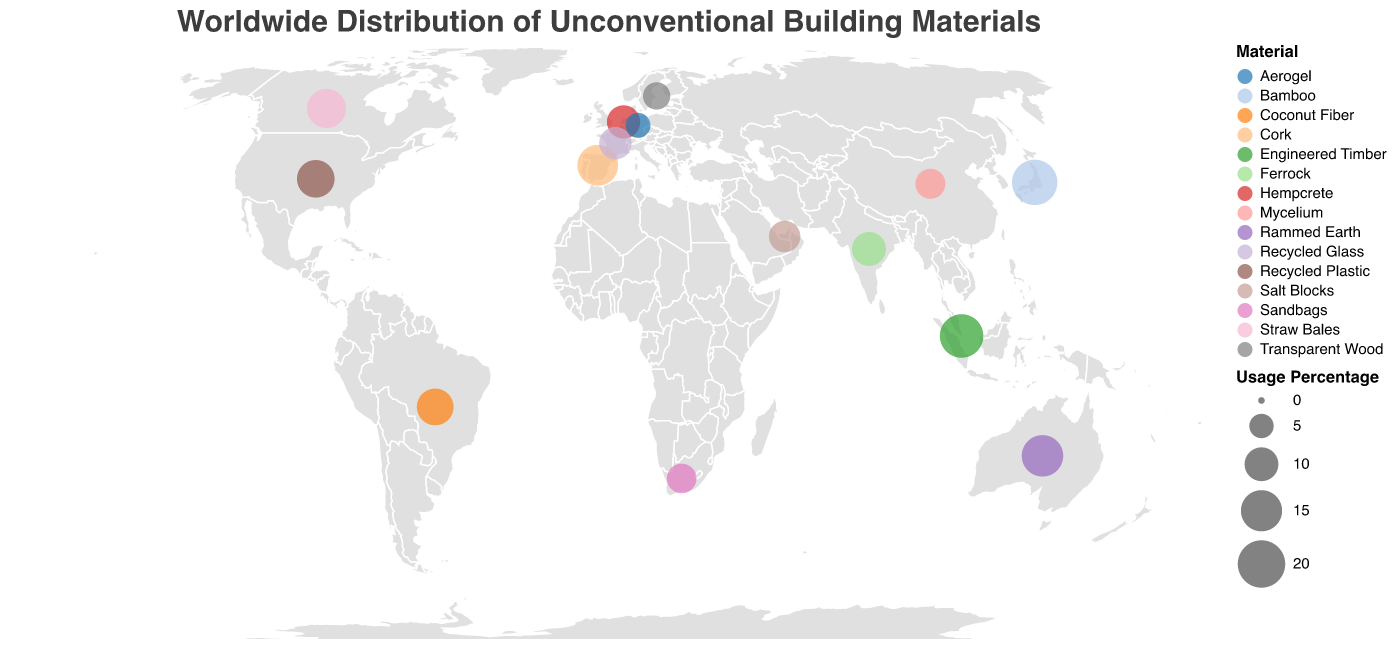What is the title of the figure? The title is usually at the top of the figure and describes its main topic. Here, it specifies the geographic distribution of unconventional building materials.
Answer: Worldwide Distribution of Unconventional Building Materials Which country has the highest usage percentage for their unconventional building material? By observing the size of the circles and the numerical values, the country with the highest percentage can be identified.
Answer: Japan What material is prominently used in Australia, and what is its usage percentage? Locate Australia on the map and look at the label and size of the circle corresponding to it.
Answer: Rammed Earth, 15.2% How does the usage percentage of Bamboo in Japan compare to Cork in Spain? Identify the usage percentages for both Bamboo in Japan and Cork in Spain, then compare these values.
Answer: Bamboo in Japan (18.3%) is higher than Cork in Spain (14.7%) Which materials are used in countries with a usage percentage greater than 15%? Identify all circles with sizes representing usage percentages greater than 15%, and then check the associated materials.
Answer: Bamboo in Japan, Rammed Earth in Australia, Engineered Timber in Singapore Total the usage percentages of Recycled Plastic in the United States and Recycled Glass in France. Locate the usage percentages for Recycled Plastic and Recycled Glass, then add these values together.
Answer: 12.5 + 9.2 = 21.7 Which two materials have the smallest usage percentages? Look for the smallest circles (or values) on the map and identify the corresponding materials.
Answer: Aerogel in Germany (5.3%) and Transparent Wood in Sweden (6.4%) Among all represented countries, which continent shows the most diverse use of unconventional building materials? Observe which continent has the most variety in materials used across different countries.
Answer: Asia Compare the usage percentage of Mycelium in China with Aerogel in Germany and identify the difference. Find the usage percentages for both Mycelium in China and Aerogel in Germany, then calculate the difference.
Answer: 7.8 - 5.3 = 2.5 Which unconventional building material is featured in South Africa and what is its significance in this context? Identify the material associated with South Africa and consider its unique application for design inspiration.
Answer: Sandbags, 7.6% 